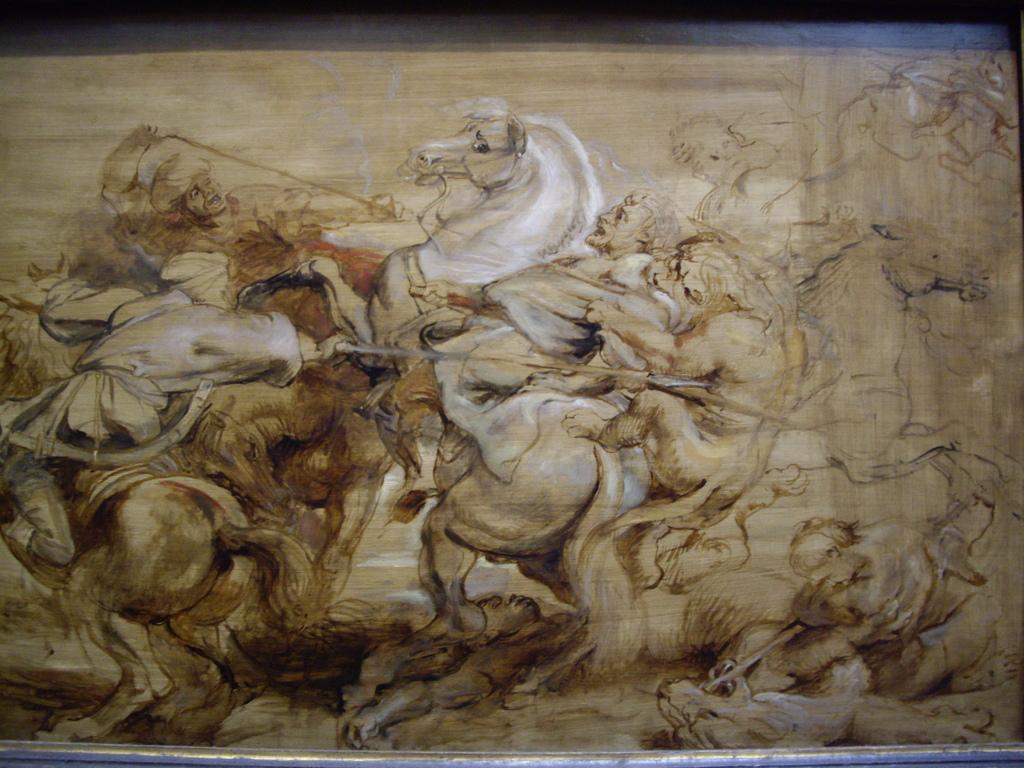In one or two sentences, can you explain what this image depicts? In this image I can see a painting which is brown and cream in color in which I can see few animals and few persons. 